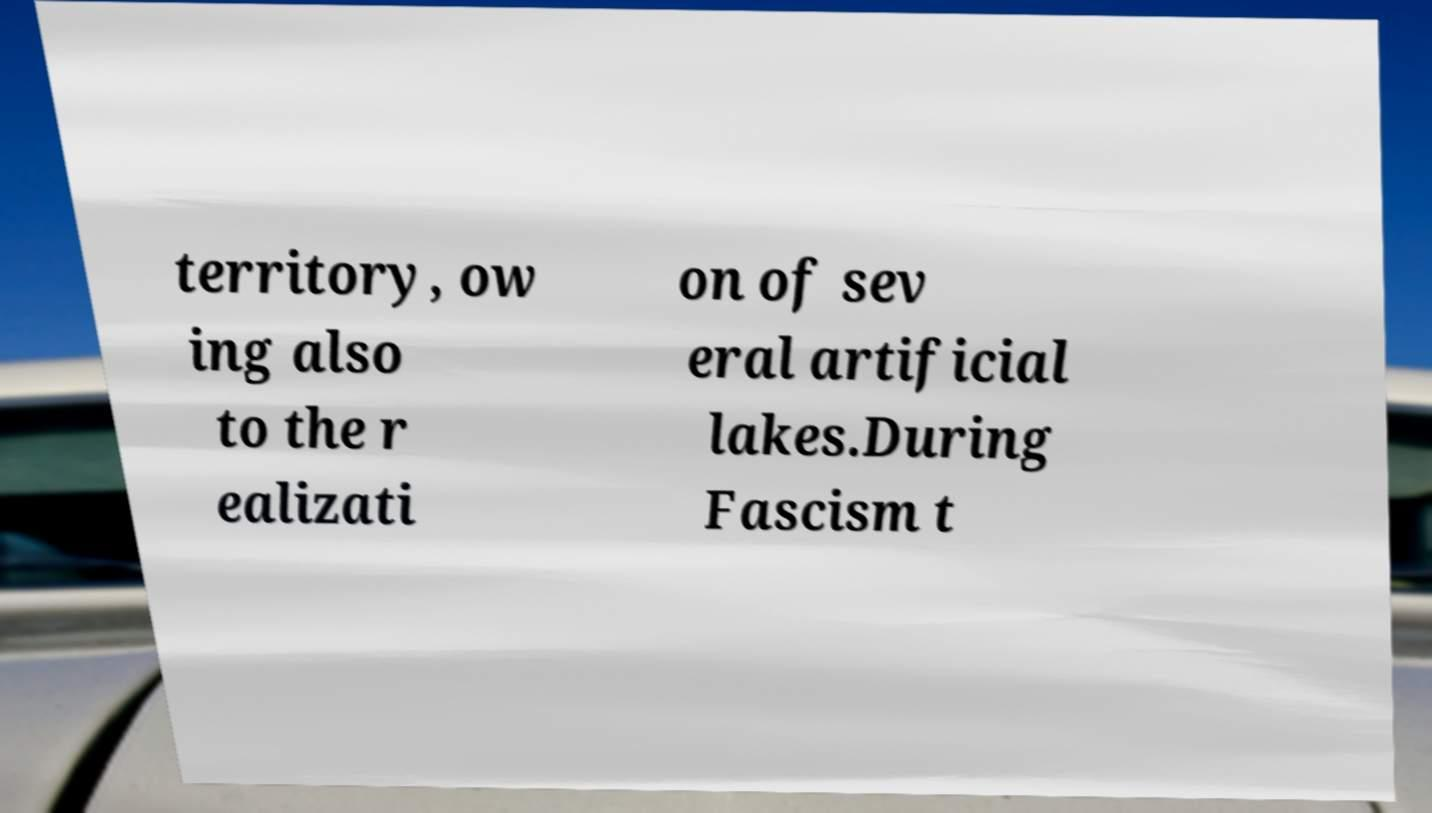For documentation purposes, I need the text within this image transcribed. Could you provide that? territory, ow ing also to the r ealizati on of sev eral artificial lakes.During Fascism t 